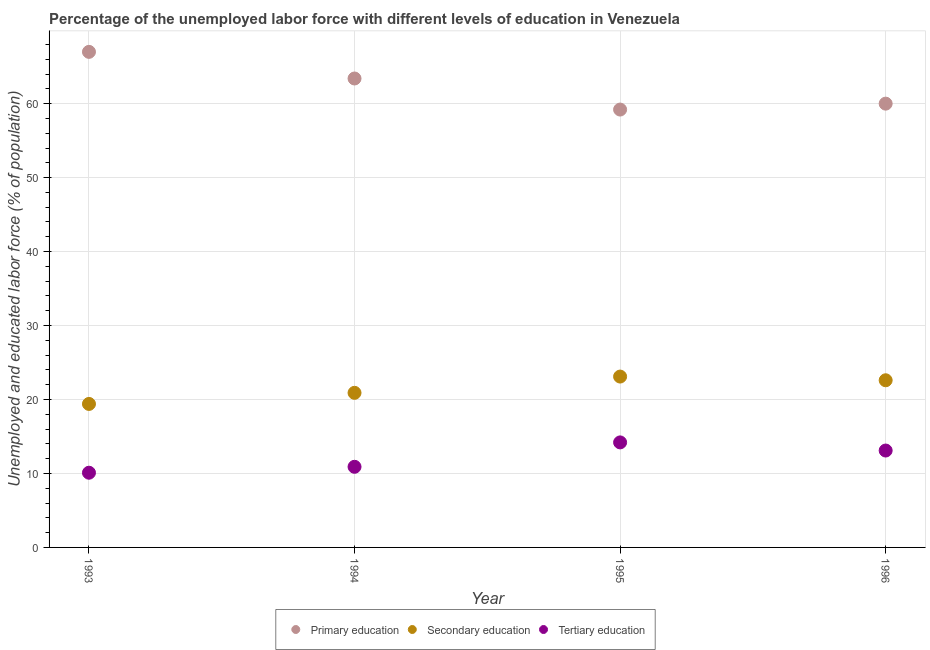How many different coloured dotlines are there?
Your answer should be compact. 3. What is the percentage of labor force who received primary education in 1994?
Give a very brief answer. 63.4. Across all years, what is the minimum percentage of labor force who received tertiary education?
Your response must be concise. 10.1. In which year was the percentage of labor force who received primary education maximum?
Offer a terse response. 1993. In which year was the percentage of labor force who received secondary education minimum?
Make the answer very short. 1993. What is the total percentage of labor force who received tertiary education in the graph?
Provide a succinct answer. 48.3. What is the difference between the percentage of labor force who received primary education in 1993 and that in 1994?
Your answer should be very brief. 3.6. What is the difference between the percentage of labor force who received primary education in 1993 and the percentage of labor force who received secondary education in 1995?
Offer a very short reply. 43.9. What is the average percentage of labor force who received secondary education per year?
Your response must be concise. 21.5. In the year 1994, what is the difference between the percentage of labor force who received secondary education and percentage of labor force who received tertiary education?
Offer a very short reply. 10. What is the ratio of the percentage of labor force who received tertiary education in 1993 to that in 1995?
Your answer should be compact. 0.71. What is the difference between the highest and the second highest percentage of labor force who received secondary education?
Your answer should be compact. 0.5. What is the difference between the highest and the lowest percentage of labor force who received tertiary education?
Give a very brief answer. 4.1. In how many years, is the percentage of labor force who received primary education greater than the average percentage of labor force who received primary education taken over all years?
Offer a very short reply. 2. Does the percentage of labor force who received tertiary education monotonically increase over the years?
Your answer should be very brief. No. Is the percentage of labor force who received tertiary education strictly greater than the percentage of labor force who received primary education over the years?
Ensure brevity in your answer.  No. How many dotlines are there?
Your response must be concise. 3. How many years are there in the graph?
Ensure brevity in your answer.  4. Are the values on the major ticks of Y-axis written in scientific E-notation?
Ensure brevity in your answer.  No. Does the graph contain any zero values?
Provide a succinct answer. No. Does the graph contain grids?
Your answer should be very brief. Yes. Where does the legend appear in the graph?
Give a very brief answer. Bottom center. How many legend labels are there?
Make the answer very short. 3. How are the legend labels stacked?
Your answer should be very brief. Horizontal. What is the title of the graph?
Provide a succinct answer. Percentage of the unemployed labor force with different levels of education in Venezuela. What is the label or title of the Y-axis?
Provide a short and direct response. Unemployed and educated labor force (% of population). What is the Unemployed and educated labor force (% of population) in Secondary education in 1993?
Provide a succinct answer. 19.4. What is the Unemployed and educated labor force (% of population) in Tertiary education in 1993?
Your answer should be very brief. 10.1. What is the Unemployed and educated labor force (% of population) in Primary education in 1994?
Provide a short and direct response. 63.4. What is the Unemployed and educated labor force (% of population) in Secondary education in 1994?
Your answer should be very brief. 20.9. What is the Unemployed and educated labor force (% of population) in Tertiary education in 1994?
Make the answer very short. 10.9. What is the Unemployed and educated labor force (% of population) in Primary education in 1995?
Offer a very short reply. 59.2. What is the Unemployed and educated labor force (% of population) in Secondary education in 1995?
Your answer should be compact. 23.1. What is the Unemployed and educated labor force (% of population) of Tertiary education in 1995?
Make the answer very short. 14.2. What is the Unemployed and educated labor force (% of population) in Primary education in 1996?
Make the answer very short. 60. What is the Unemployed and educated labor force (% of population) of Secondary education in 1996?
Provide a short and direct response. 22.6. What is the Unemployed and educated labor force (% of population) in Tertiary education in 1996?
Offer a very short reply. 13.1. Across all years, what is the maximum Unemployed and educated labor force (% of population) in Secondary education?
Ensure brevity in your answer.  23.1. Across all years, what is the maximum Unemployed and educated labor force (% of population) of Tertiary education?
Keep it short and to the point. 14.2. Across all years, what is the minimum Unemployed and educated labor force (% of population) in Primary education?
Provide a short and direct response. 59.2. Across all years, what is the minimum Unemployed and educated labor force (% of population) of Secondary education?
Offer a terse response. 19.4. Across all years, what is the minimum Unemployed and educated labor force (% of population) of Tertiary education?
Provide a short and direct response. 10.1. What is the total Unemployed and educated labor force (% of population) of Primary education in the graph?
Make the answer very short. 249.6. What is the total Unemployed and educated labor force (% of population) of Secondary education in the graph?
Give a very brief answer. 86. What is the total Unemployed and educated labor force (% of population) of Tertiary education in the graph?
Give a very brief answer. 48.3. What is the difference between the Unemployed and educated labor force (% of population) in Primary education in 1993 and that in 1994?
Your answer should be compact. 3.6. What is the difference between the Unemployed and educated labor force (% of population) in Secondary education in 1993 and that in 1994?
Give a very brief answer. -1.5. What is the difference between the Unemployed and educated labor force (% of population) of Primary education in 1993 and that in 1995?
Your answer should be very brief. 7.8. What is the difference between the Unemployed and educated labor force (% of population) of Secondary education in 1993 and that in 1995?
Offer a terse response. -3.7. What is the difference between the Unemployed and educated labor force (% of population) in Secondary education in 1993 and that in 1996?
Your answer should be very brief. -3.2. What is the difference between the Unemployed and educated labor force (% of population) of Primary education in 1994 and that in 1995?
Give a very brief answer. 4.2. What is the difference between the Unemployed and educated labor force (% of population) of Secondary education in 1994 and that in 1995?
Keep it short and to the point. -2.2. What is the difference between the Unemployed and educated labor force (% of population) of Tertiary education in 1994 and that in 1995?
Your answer should be compact. -3.3. What is the difference between the Unemployed and educated labor force (% of population) of Primary education in 1994 and that in 1996?
Keep it short and to the point. 3.4. What is the difference between the Unemployed and educated labor force (% of population) of Tertiary education in 1994 and that in 1996?
Offer a terse response. -2.2. What is the difference between the Unemployed and educated labor force (% of population) of Secondary education in 1995 and that in 1996?
Give a very brief answer. 0.5. What is the difference between the Unemployed and educated labor force (% of population) in Primary education in 1993 and the Unemployed and educated labor force (% of population) in Secondary education in 1994?
Provide a short and direct response. 46.1. What is the difference between the Unemployed and educated labor force (% of population) of Primary education in 1993 and the Unemployed and educated labor force (% of population) of Tertiary education in 1994?
Your answer should be compact. 56.1. What is the difference between the Unemployed and educated labor force (% of population) in Secondary education in 1993 and the Unemployed and educated labor force (% of population) in Tertiary education in 1994?
Offer a very short reply. 8.5. What is the difference between the Unemployed and educated labor force (% of population) of Primary education in 1993 and the Unemployed and educated labor force (% of population) of Secondary education in 1995?
Your answer should be very brief. 43.9. What is the difference between the Unemployed and educated labor force (% of population) in Primary education in 1993 and the Unemployed and educated labor force (% of population) in Tertiary education in 1995?
Your answer should be very brief. 52.8. What is the difference between the Unemployed and educated labor force (% of population) in Secondary education in 1993 and the Unemployed and educated labor force (% of population) in Tertiary education in 1995?
Give a very brief answer. 5.2. What is the difference between the Unemployed and educated labor force (% of population) of Primary education in 1993 and the Unemployed and educated labor force (% of population) of Secondary education in 1996?
Your answer should be compact. 44.4. What is the difference between the Unemployed and educated labor force (% of population) in Primary education in 1993 and the Unemployed and educated labor force (% of population) in Tertiary education in 1996?
Offer a very short reply. 53.9. What is the difference between the Unemployed and educated labor force (% of population) of Primary education in 1994 and the Unemployed and educated labor force (% of population) of Secondary education in 1995?
Offer a very short reply. 40.3. What is the difference between the Unemployed and educated labor force (% of population) in Primary education in 1994 and the Unemployed and educated labor force (% of population) in Tertiary education in 1995?
Make the answer very short. 49.2. What is the difference between the Unemployed and educated labor force (% of population) of Secondary education in 1994 and the Unemployed and educated labor force (% of population) of Tertiary education in 1995?
Give a very brief answer. 6.7. What is the difference between the Unemployed and educated labor force (% of population) of Primary education in 1994 and the Unemployed and educated labor force (% of population) of Secondary education in 1996?
Provide a short and direct response. 40.8. What is the difference between the Unemployed and educated labor force (% of population) in Primary education in 1994 and the Unemployed and educated labor force (% of population) in Tertiary education in 1996?
Give a very brief answer. 50.3. What is the difference between the Unemployed and educated labor force (% of population) of Secondary education in 1994 and the Unemployed and educated labor force (% of population) of Tertiary education in 1996?
Your answer should be very brief. 7.8. What is the difference between the Unemployed and educated labor force (% of population) of Primary education in 1995 and the Unemployed and educated labor force (% of population) of Secondary education in 1996?
Your answer should be compact. 36.6. What is the difference between the Unemployed and educated labor force (% of population) of Primary education in 1995 and the Unemployed and educated labor force (% of population) of Tertiary education in 1996?
Your response must be concise. 46.1. What is the average Unemployed and educated labor force (% of population) of Primary education per year?
Your response must be concise. 62.4. What is the average Unemployed and educated labor force (% of population) of Tertiary education per year?
Ensure brevity in your answer.  12.07. In the year 1993, what is the difference between the Unemployed and educated labor force (% of population) in Primary education and Unemployed and educated labor force (% of population) in Secondary education?
Your answer should be compact. 47.6. In the year 1993, what is the difference between the Unemployed and educated labor force (% of population) in Primary education and Unemployed and educated labor force (% of population) in Tertiary education?
Offer a very short reply. 56.9. In the year 1993, what is the difference between the Unemployed and educated labor force (% of population) of Secondary education and Unemployed and educated labor force (% of population) of Tertiary education?
Offer a terse response. 9.3. In the year 1994, what is the difference between the Unemployed and educated labor force (% of population) of Primary education and Unemployed and educated labor force (% of population) of Secondary education?
Give a very brief answer. 42.5. In the year 1994, what is the difference between the Unemployed and educated labor force (% of population) in Primary education and Unemployed and educated labor force (% of population) in Tertiary education?
Your answer should be compact. 52.5. In the year 1995, what is the difference between the Unemployed and educated labor force (% of population) of Primary education and Unemployed and educated labor force (% of population) of Secondary education?
Your answer should be compact. 36.1. In the year 1995, what is the difference between the Unemployed and educated labor force (% of population) of Primary education and Unemployed and educated labor force (% of population) of Tertiary education?
Offer a very short reply. 45. In the year 1996, what is the difference between the Unemployed and educated labor force (% of population) of Primary education and Unemployed and educated labor force (% of population) of Secondary education?
Offer a terse response. 37.4. In the year 1996, what is the difference between the Unemployed and educated labor force (% of population) of Primary education and Unemployed and educated labor force (% of population) of Tertiary education?
Offer a very short reply. 46.9. In the year 1996, what is the difference between the Unemployed and educated labor force (% of population) in Secondary education and Unemployed and educated labor force (% of population) in Tertiary education?
Provide a succinct answer. 9.5. What is the ratio of the Unemployed and educated labor force (% of population) in Primary education in 1993 to that in 1994?
Give a very brief answer. 1.06. What is the ratio of the Unemployed and educated labor force (% of population) in Secondary education in 1993 to that in 1994?
Your answer should be compact. 0.93. What is the ratio of the Unemployed and educated labor force (% of population) in Tertiary education in 1993 to that in 1994?
Provide a short and direct response. 0.93. What is the ratio of the Unemployed and educated labor force (% of population) of Primary education in 1993 to that in 1995?
Provide a short and direct response. 1.13. What is the ratio of the Unemployed and educated labor force (% of population) in Secondary education in 1993 to that in 1995?
Offer a terse response. 0.84. What is the ratio of the Unemployed and educated labor force (% of population) in Tertiary education in 1993 to that in 1995?
Provide a succinct answer. 0.71. What is the ratio of the Unemployed and educated labor force (% of population) of Primary education in 1993 to that in 1996?
Offer a terse response. 1.12. What is the ratio of the Unemployed and educated labor force (% of population) of Secondary education in 1993 to that in 1996?
Provide a short and direct response. 0.86. What is the ratio of the Unemployed and educated labor force (% of population) in Tertiary education in 1993 to that in 1996?
Ensure brevity in your answer.  0.77. What is the ratio of the Unemployed and educated labor force (% of population) in Primary education in 1994 to that in 1995?
Your response must be concise. 1.07. What is the ratio of the Unemployed and educated labor force (% of population) of Secondary education in 1994 to that in 1995?
Keep it short and to the point. 0.9. What is the ratio of the Unemployed and educated labor force (% of population) of Tertiary education in 1994 to that in 1995?
Make the answer very short. 0.77. What is the ratio of the Unemployed and educated labor force (% of population) of Primary education in 1994 to that in 1996?
Keep it short and to the point. 1.06. What is the ratio of the Unemployed and educated labor force (% of population) in Secondary education in 1994 to that in 1996?
Give a very brief answer. 0.92. What is the ratio of the Unemployed and educated labor force (% of population) of Tertiary education in 1994 to that in 1996?
Offer a terse response. 0.83. What is the ratio of the Unemployed and educated labor force (% of population) in Primary education in 1995 to that in 1996?
Keep it short and to the point. 0.99. What is the ratio of the Unemployed and educated labor force (% of population) in Secondary education in 1995 to that in 1996?
Give a very brief answer. 1.02. What is the ratio of the Unemployed and educated labor force (% of population) in Tertiary education in 1995 to that in 1996?
Your response must be concise. 1.08. What is the difference between the highest and the lowest Unemployed and educated labor force (% of population) in Secondary education?
Offer a very short reply. 3.7. 